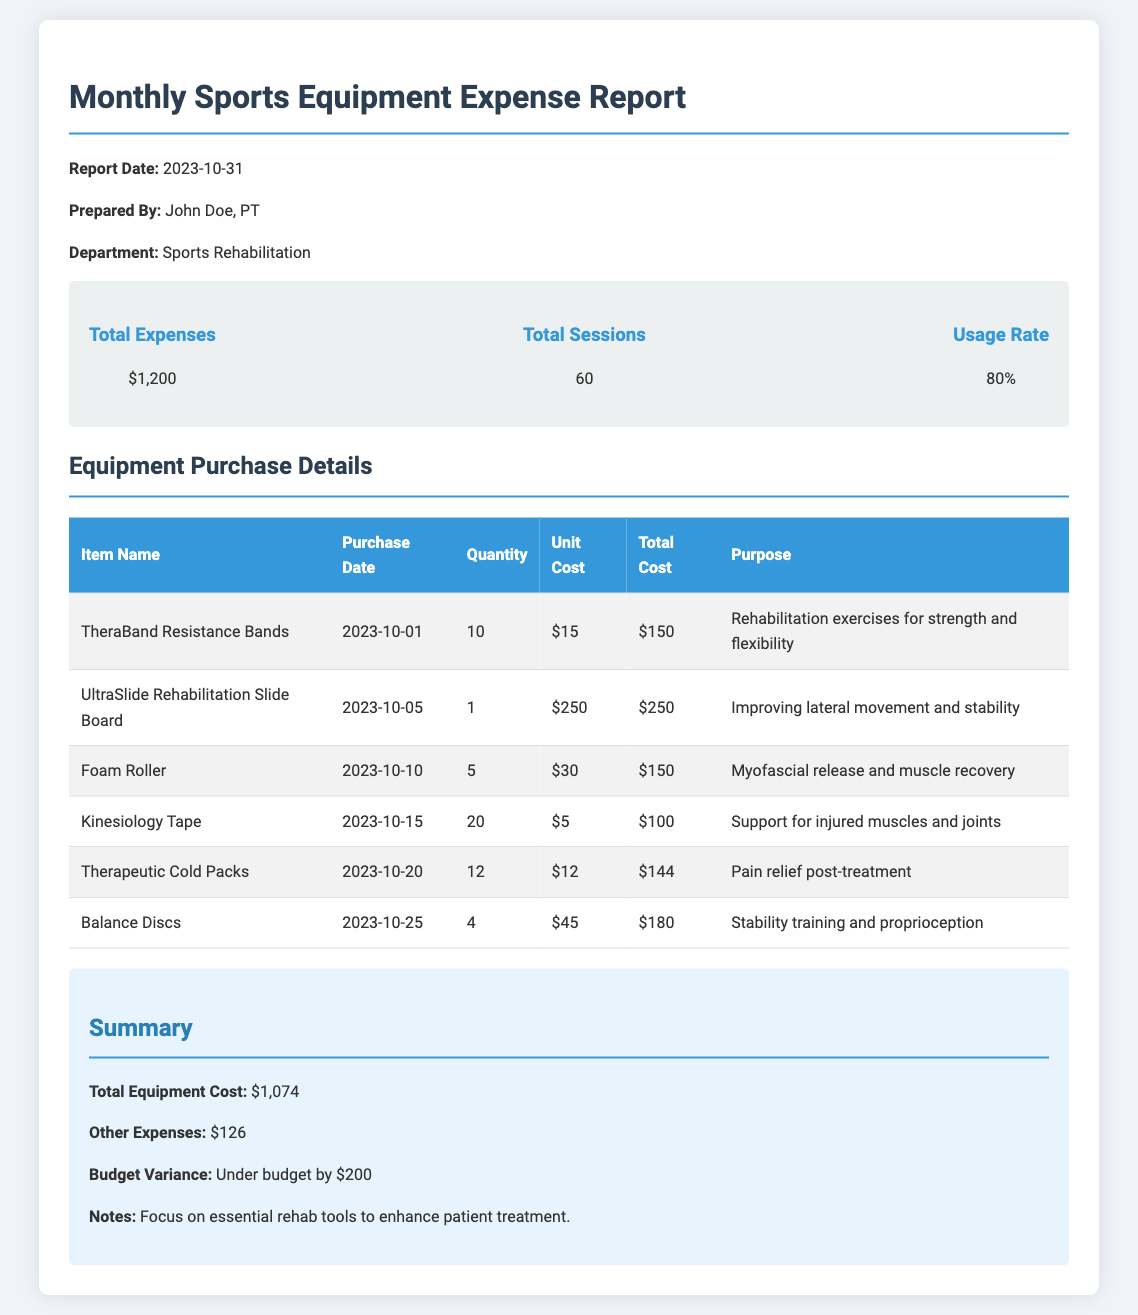What is the report date? The report date is indicated at the top of the document.
Answer: 2023-10-31 Who prepared the report? The individual who prepared the report is mentioned in the document.
Answer: John Doe, PT What is the total expense amount? The total expenses are summarized in the overview section.
Answer: $1,200 How many total sessions are recorded? The total number of sessions is specified in the overview section.
Answer: 60 What is the purpose of the Foam Roller? The purpose is included in the table detailing equipment purchase.
Answer: Myofascial release and muscle recovery What is the quantity of Kinesiology Tape purchased? The quantity of Kinesiology Tape is noted in the equipment details table.
Answer: 20 What is the total cost for the TheraBand Resistance Bands? The total cost can be found next to the item in the equipment table.
Answer: $150 What is the budget variance? The budget variance is provided in the summary section.
Answer: Under budget by $200 What is the usage rate of the equipment? The usage rate is represented in the overview section.
Answer: 80% 